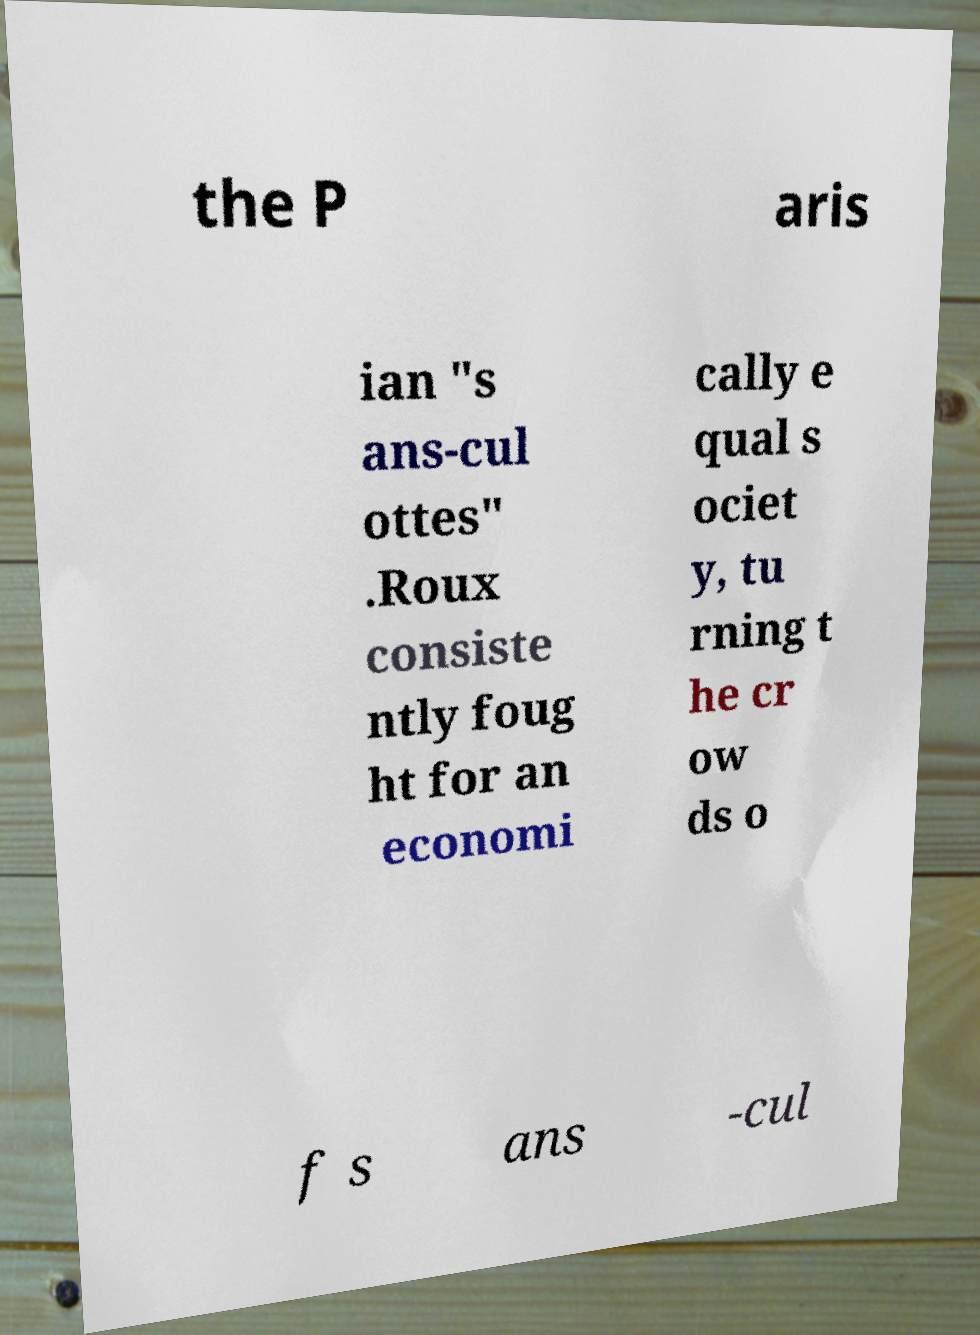Please identify and transcribe the text found in this image. the P aris ian "s ans-cul ottes" .Roux consiste ntly foug ht for an economi cally e qual s ociet y, tu rning t he cr ow ds o f s ans -cul 